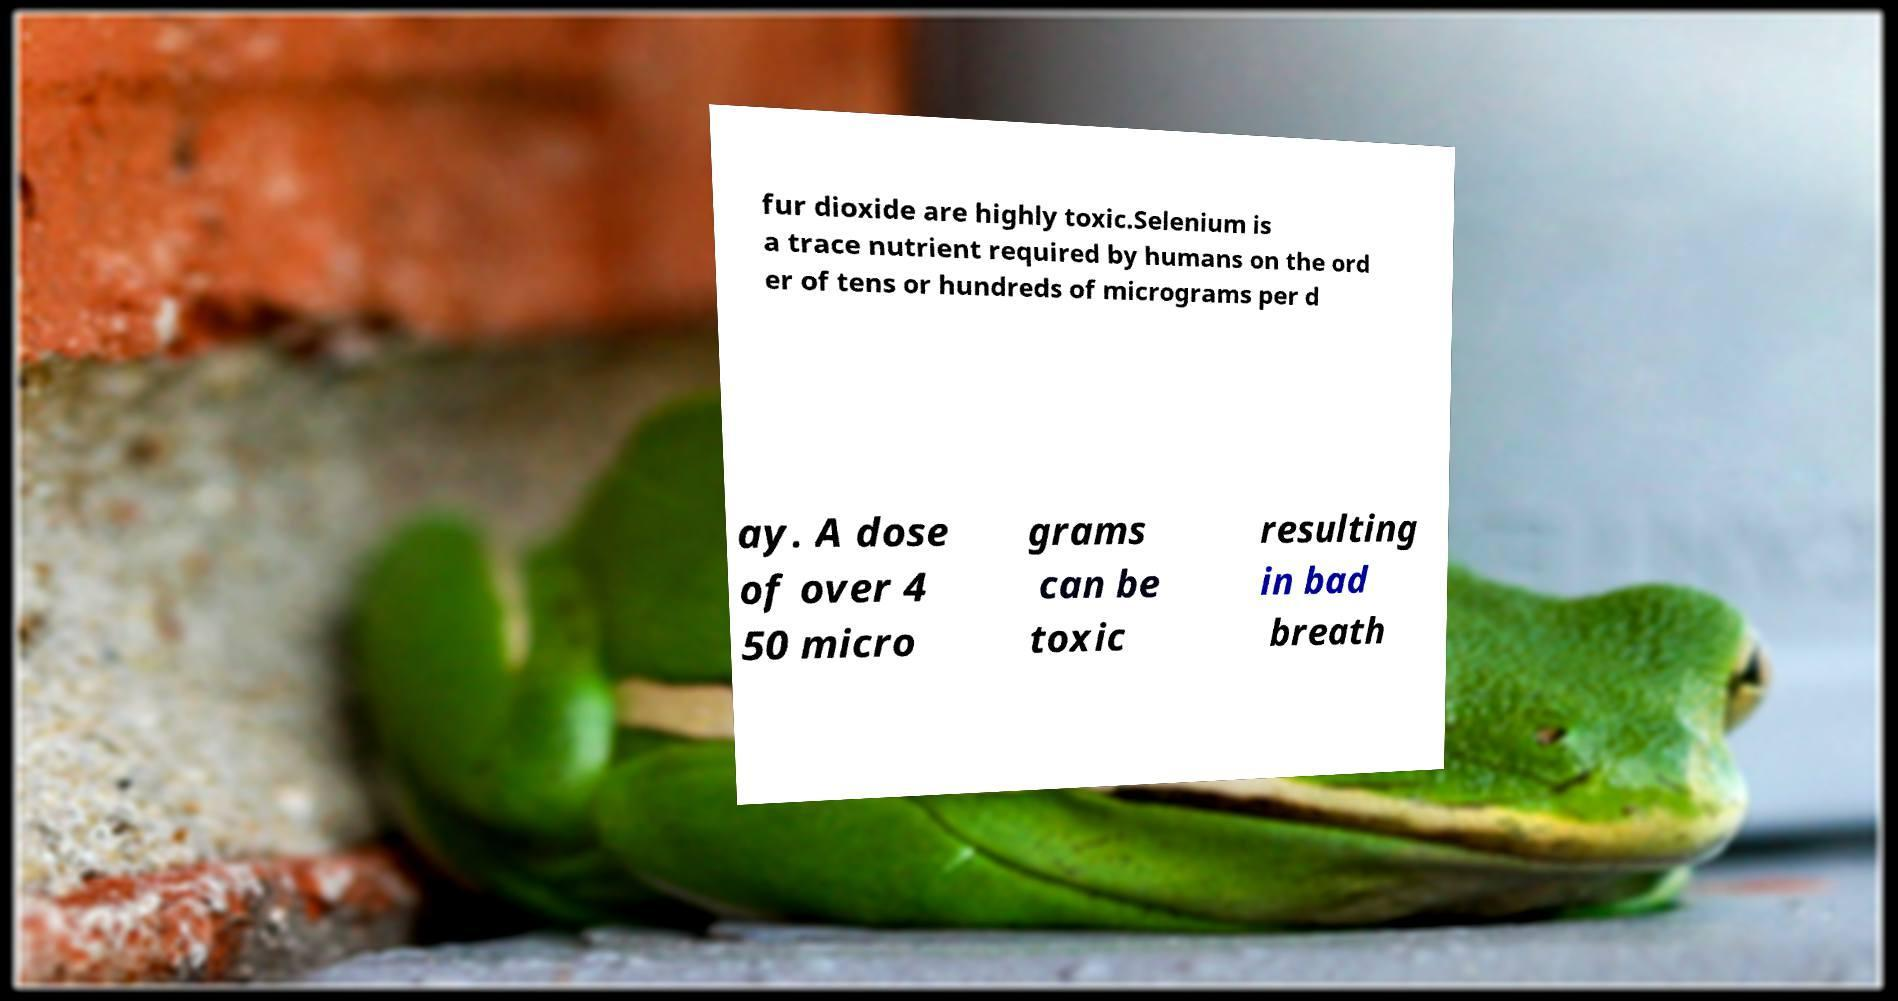Can you accurately transcribe the text from the provided image for me? fur dioxide are highly toxic.Selenium is a trace nutrient required by humans on the ord er of tens or hundreds of micrograms per d ay. A dose of over 4 50 micro grams can be toxic resulting in bad breath 